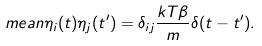<formula> <loc_0><loc_0><loc_500><loc_500>\ m e a n { \eta _ { i } ( t ) \eta _ { j } ( t ^ { \prime } ) } = \delta _ { i j } \frac { k T \beta } { m } \delta ( t - t ^ { \prime } ) .</formula> 